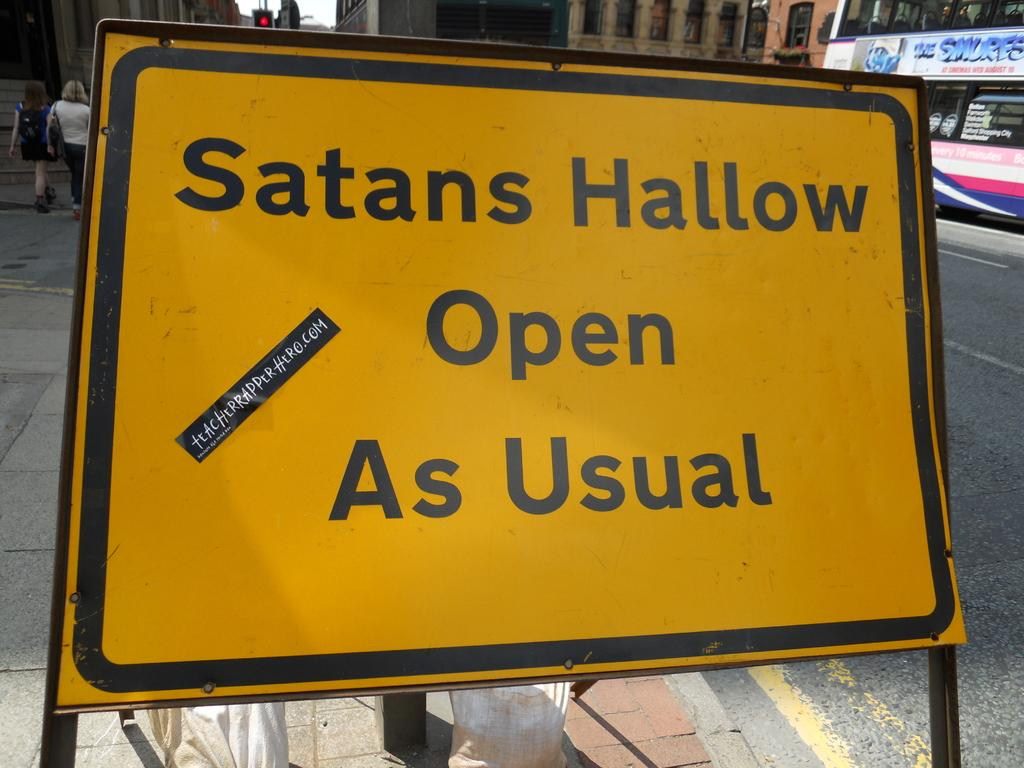<image>
Relay a brief, clear account of the picture shown. A yellow sign that says Satans Hallow Open As Usual 